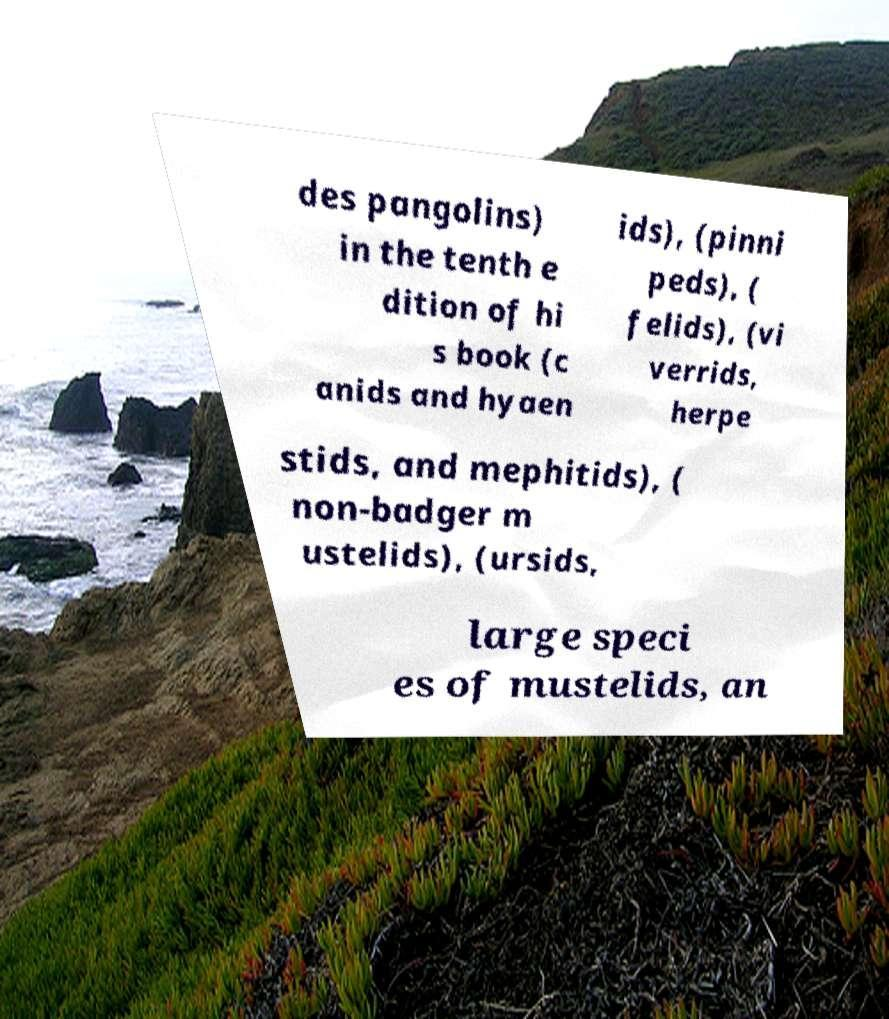For documentation purposes, I need the text within this image transcribed. Could you provide that? des pangolins) in the tenth e dition of hi s book (c anids and hyaen ids), (pinni peds), ( felids), (vi verrids, herpe stids, and mephitids), ( non-badger m ustelids), (ursids, large speci es of mustelids, an 